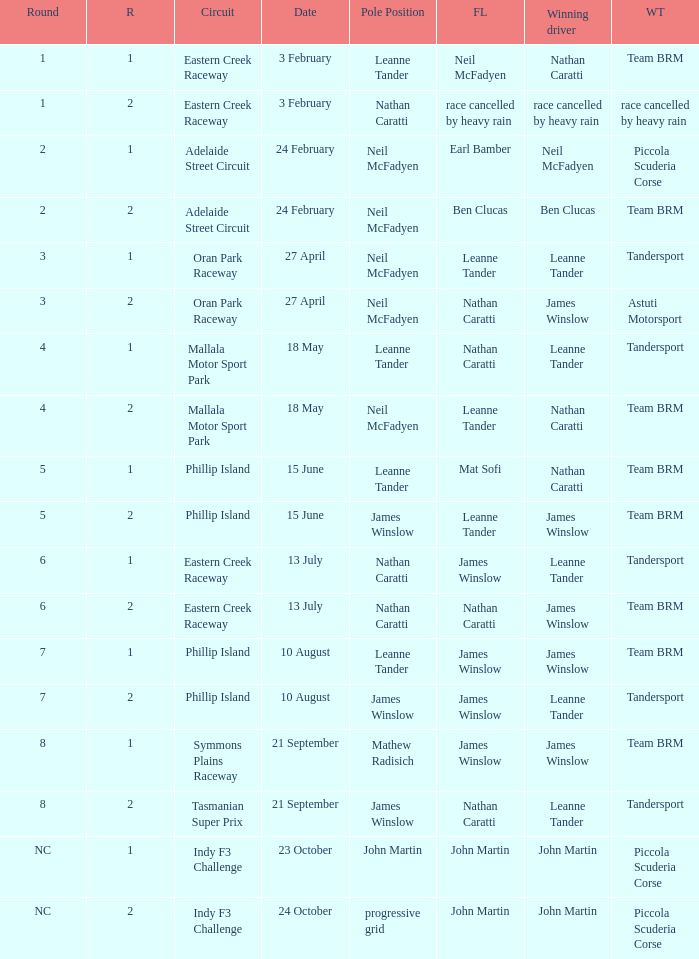Which race number in the Indy F3 Challenge circuit had John Martin in pole position? 1.0. 